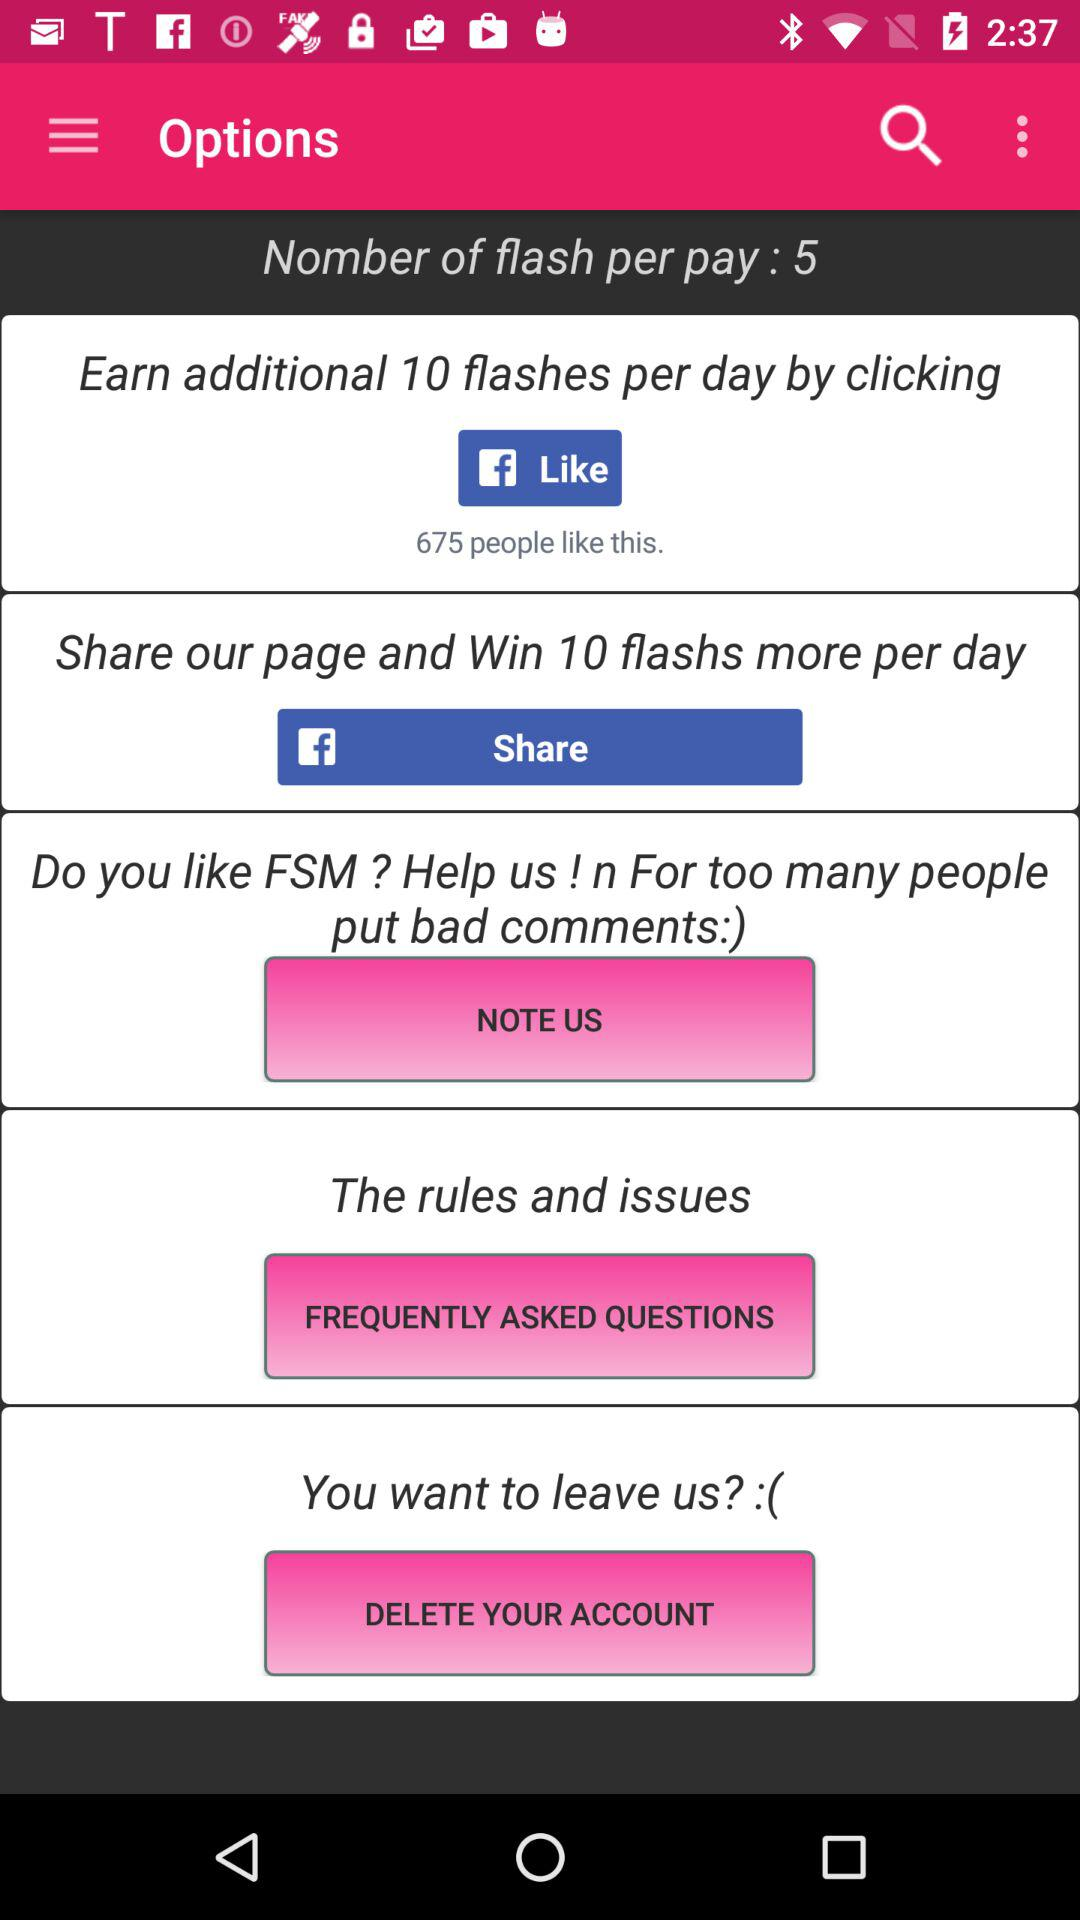How many flashs do I get per day for free?
Answer the question using a single word or phrase. 5 